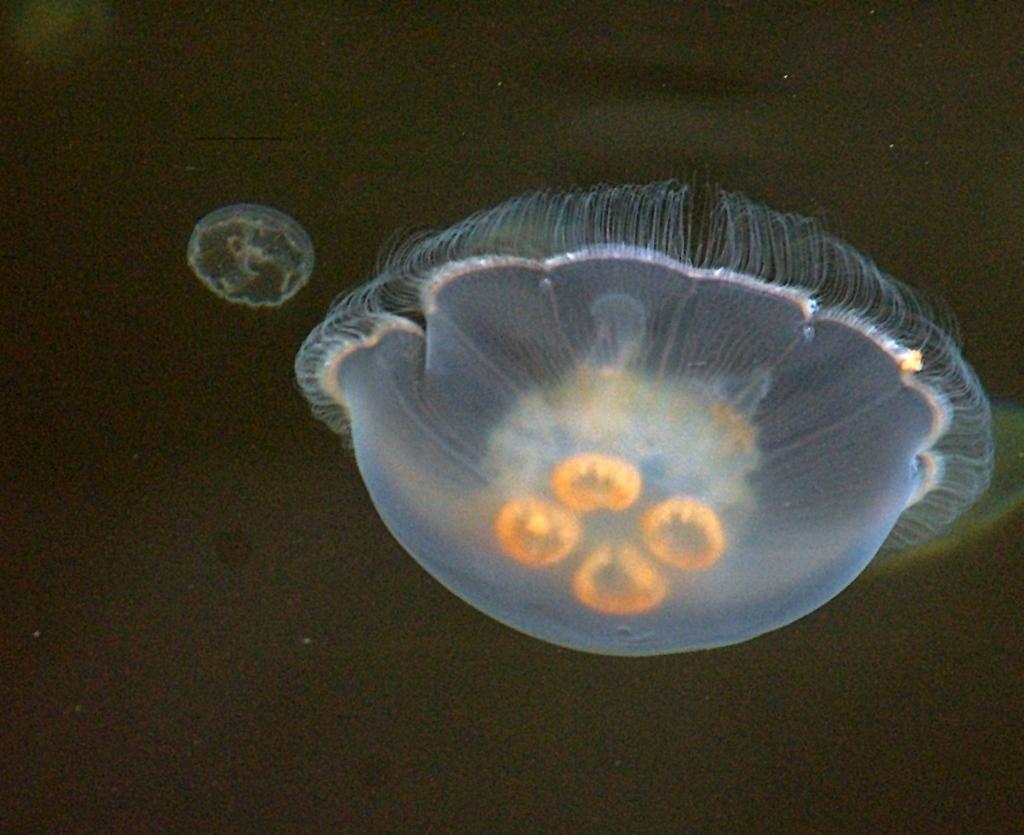How would you summarize this image in a sentence or two? In this image we can see two aquatic plants. 